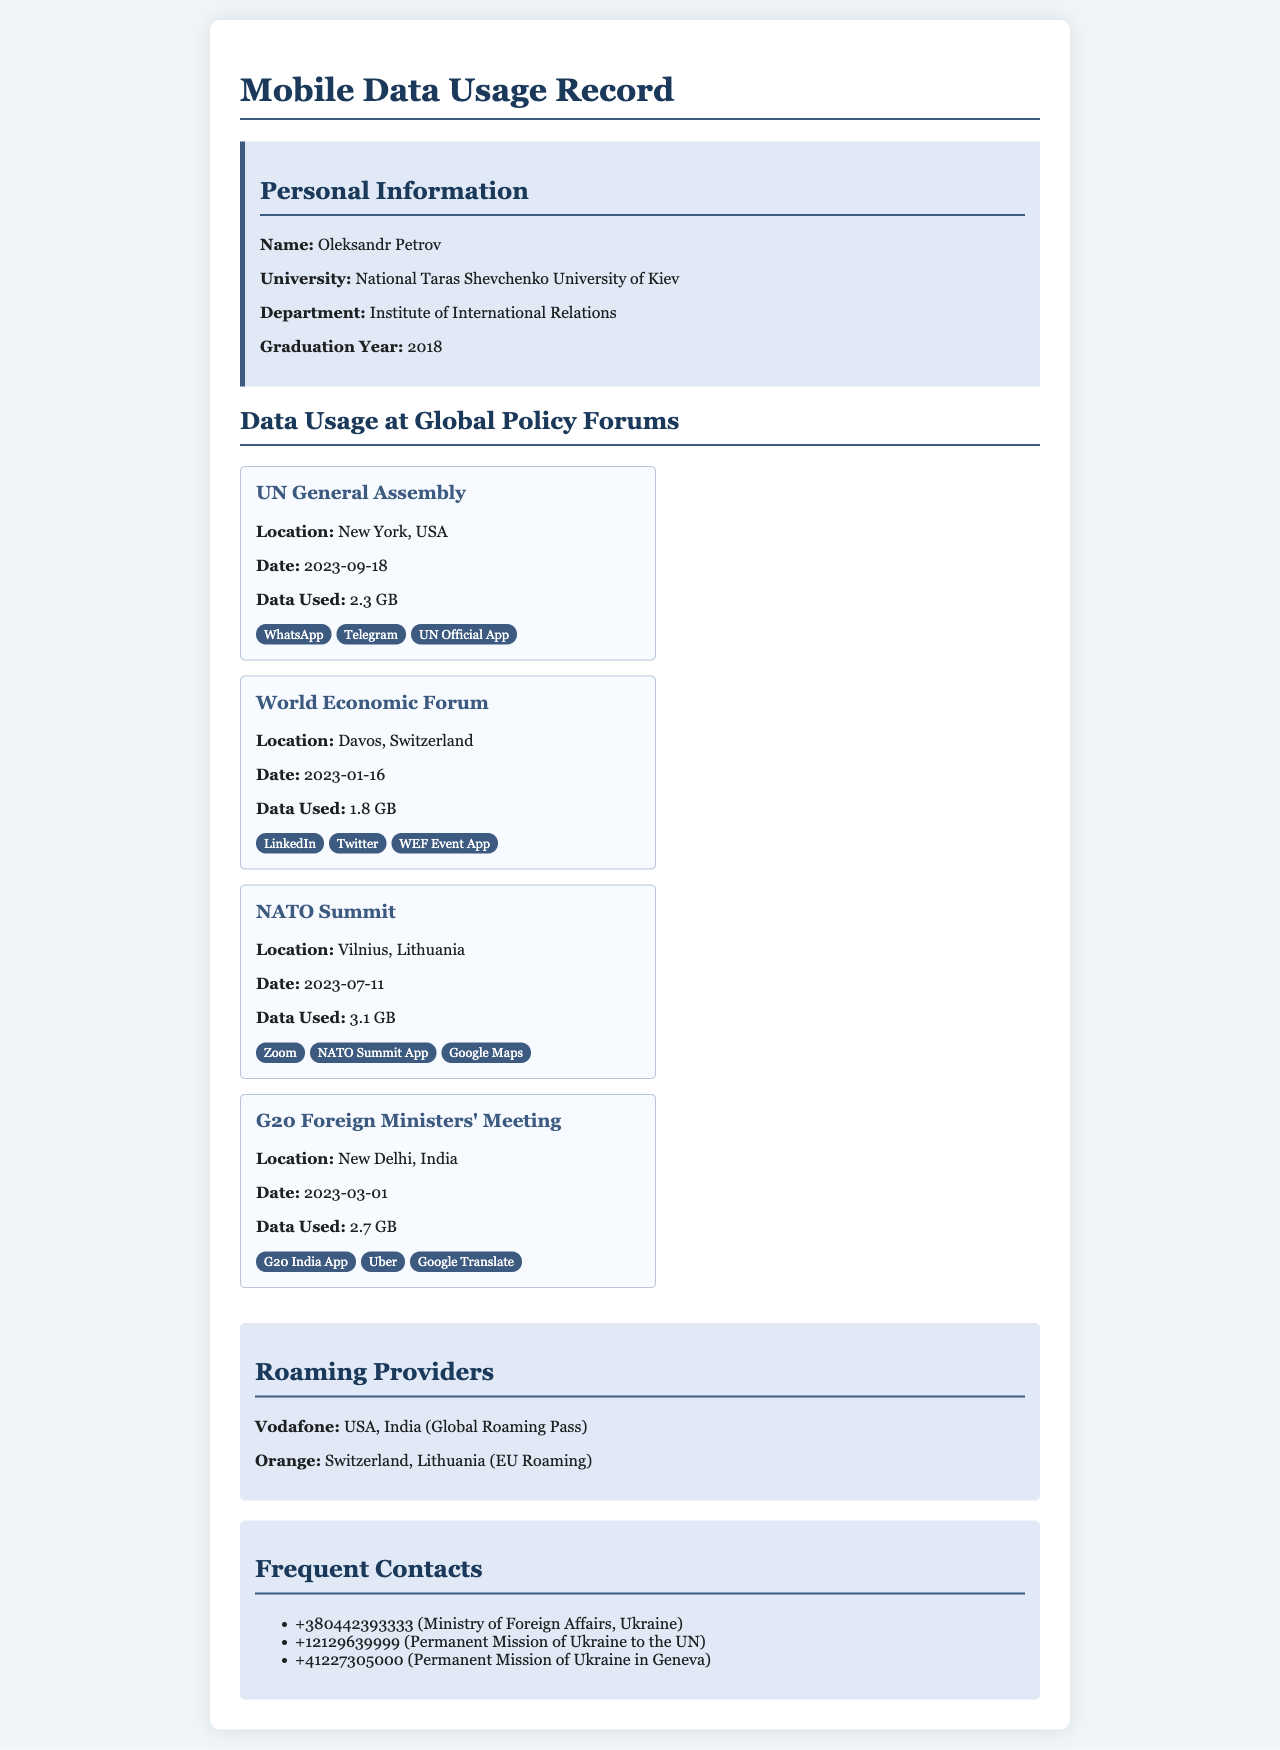what is the name of the individual in the records? The name of the individual is mentioned in the personal information section of the document.
Answer: Oleksandr Petrov where was the NATO Summit held? The location of the NATO Summit is specified in the data usage section of the document.
Answer: Vilnius, Lithuania how much data was used at the UN General Assembly? The data used at the UN General Assembly is provided under the event details.
Answer: 2.3 GB which app was used for the G20 Foreign Ministers' Meeting? The apps used for the G20 meeting are listed in the corresponding event card of the document.
Answer: G20 India App what is the date of the World Economic Forum? The date for the World Economic Forum is stated explicitly in the event card.
Answer: 2023-01-16 how many roaming providers are mentioned in the document? The document lists the roaming providers in a specific section, which can be counted.
Answer: 2 which app was most likely used for video conferencing at the NATO Summit? The apps used during the NATO Summit include various options focused on communication.
Answer: Zoom which country is associated with the Permanent Mission of Ukraine to the UN? The document provides contact information for the Permanent Mission, indicating its location.
Answer: USA 